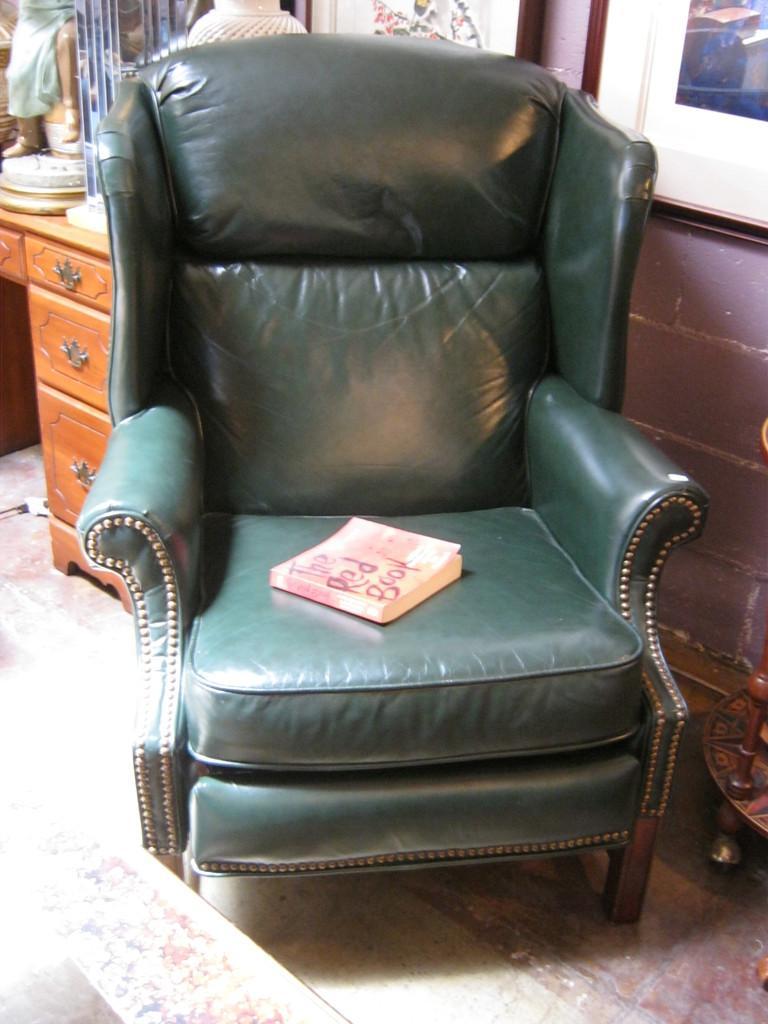Could you give a brief overview of what you see in this image? In this picture there is a green color sofa. There is a book on the sofa. There is a desk, vase and a statue on the desk. There is a brown color table. 